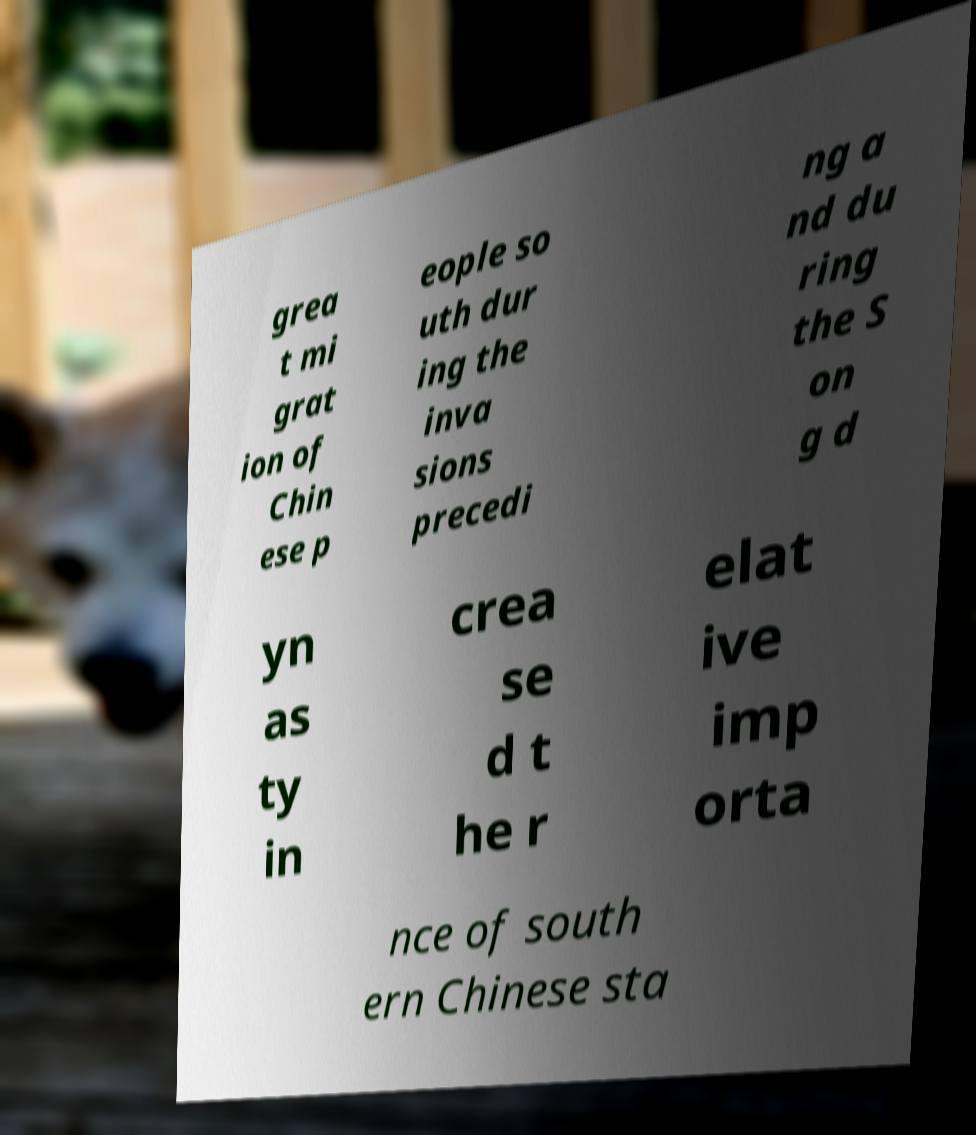There's text embedded in this image that I need extracted. Can you transcribe it verbatim? grea t mi grat ion of Chin ese p eople so uth dur ing the inva sions precedi ng a nd du ring the S on g d yn as ty in crea se d t he r elat ive imp orta nce of south ern Chinese sta 